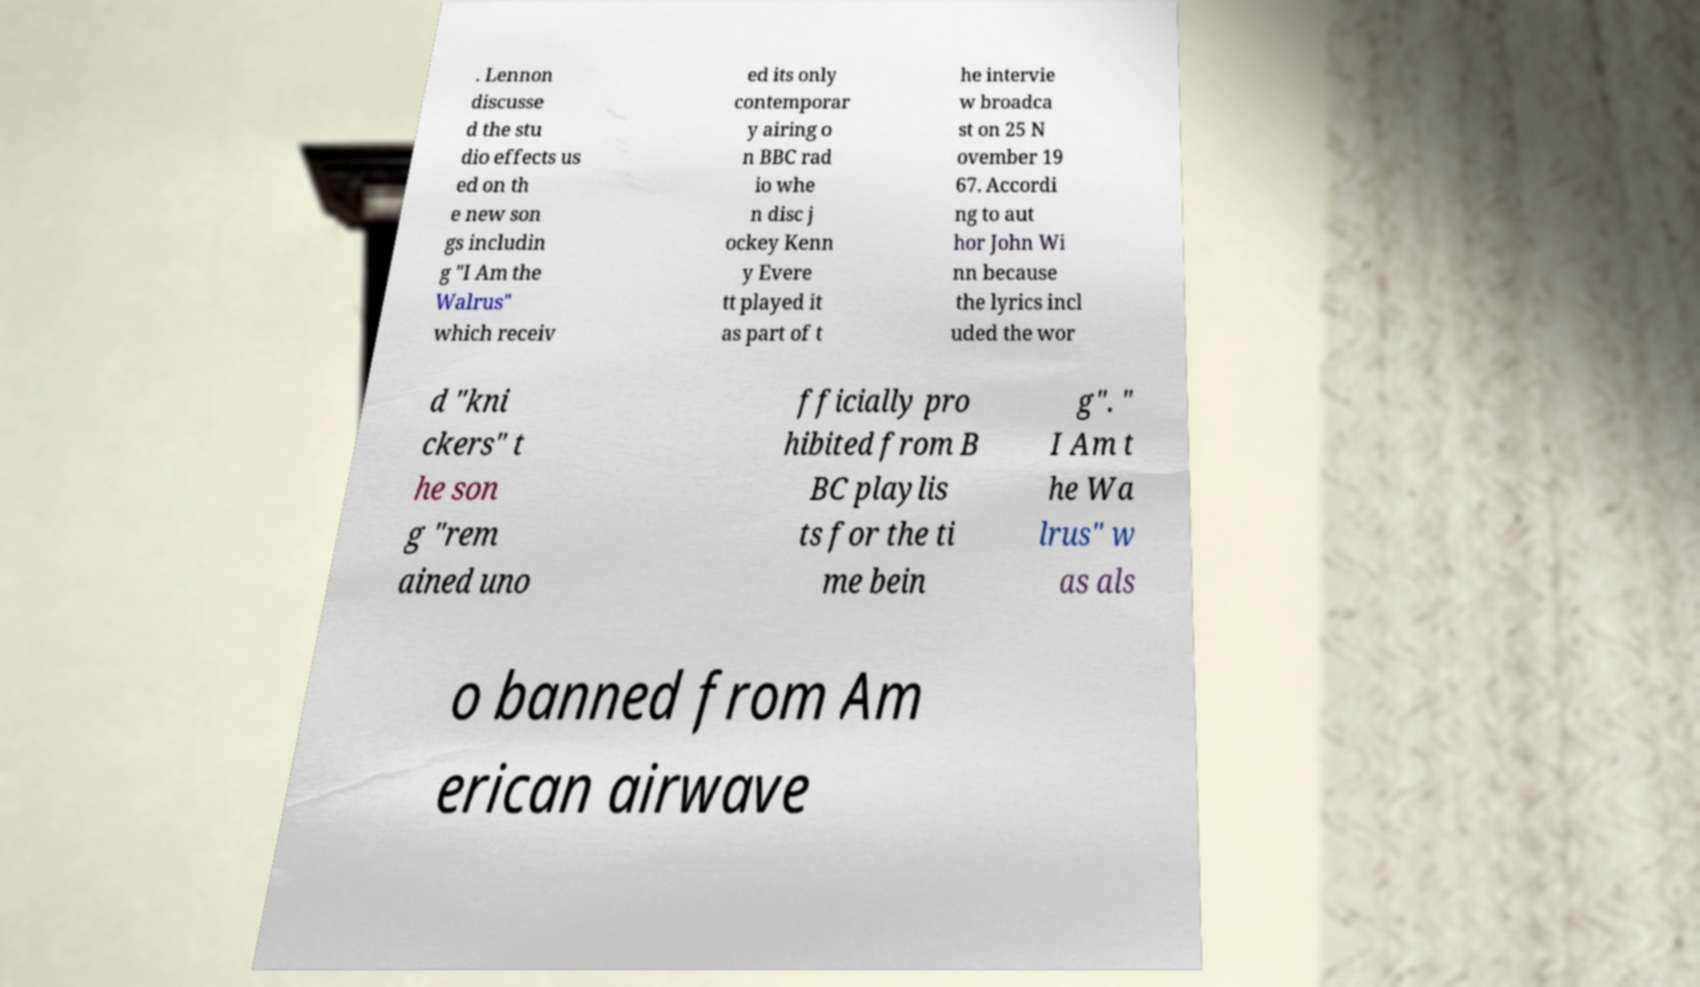Please identify and transcribe the text found in this image. . Lennon discusse d the stu dio effects us ed on th e new son gs includin g "I Am the Walrus" which receiv ed its only contemporar y airing o n BBC rad io whe n disc j ockey Kenn y Evere tt played it as part of t he intervie w broadca st on 25 N ovember 19 67. Accordi ng to aut hor John Wi nn because the lyrics incl uded the wor d "kni ckers" t he son g "rem ained uno fficially pro hibited from B BC playlis ts for the ti me bein g". " I Am t he Wa lrus" w as als o banned from Am erican airwave 